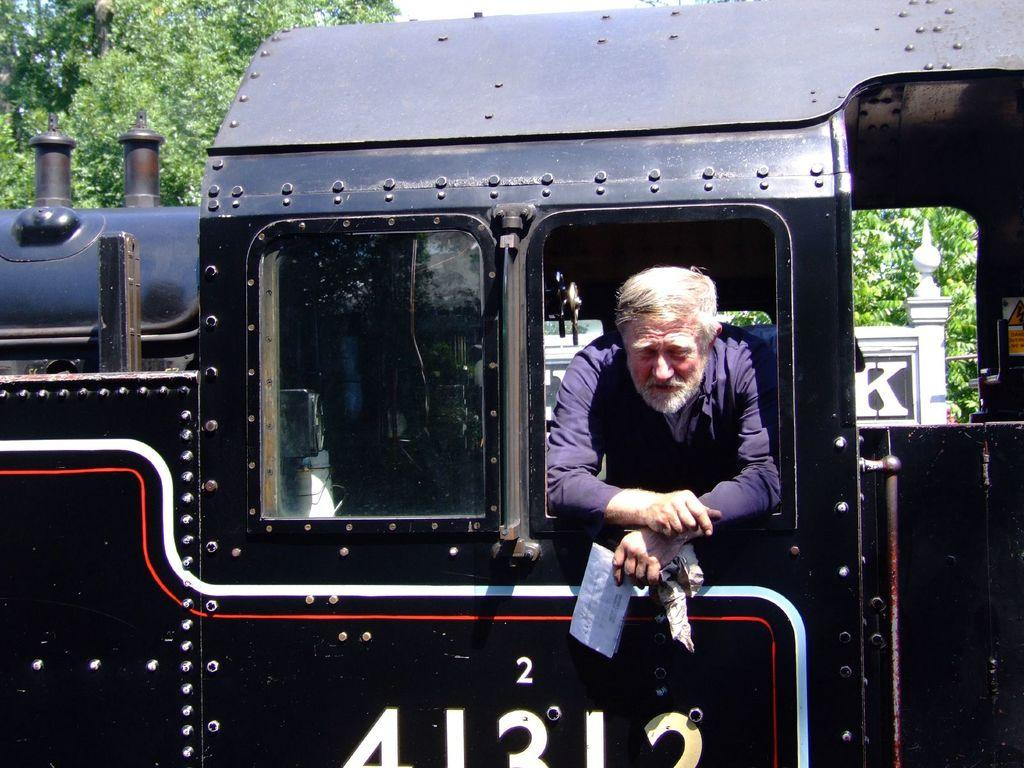What is the main subject in the center of the image? There is a train in the center of the image. Can you describe the man inside the train? A man is present in the train, and he is holding a paper. What can be seen at the top of the image? There is a tree at the top of the image. What type of cake is being pushed by the man in the image? There is no cake present in the image, nor is the man pushing anything. 